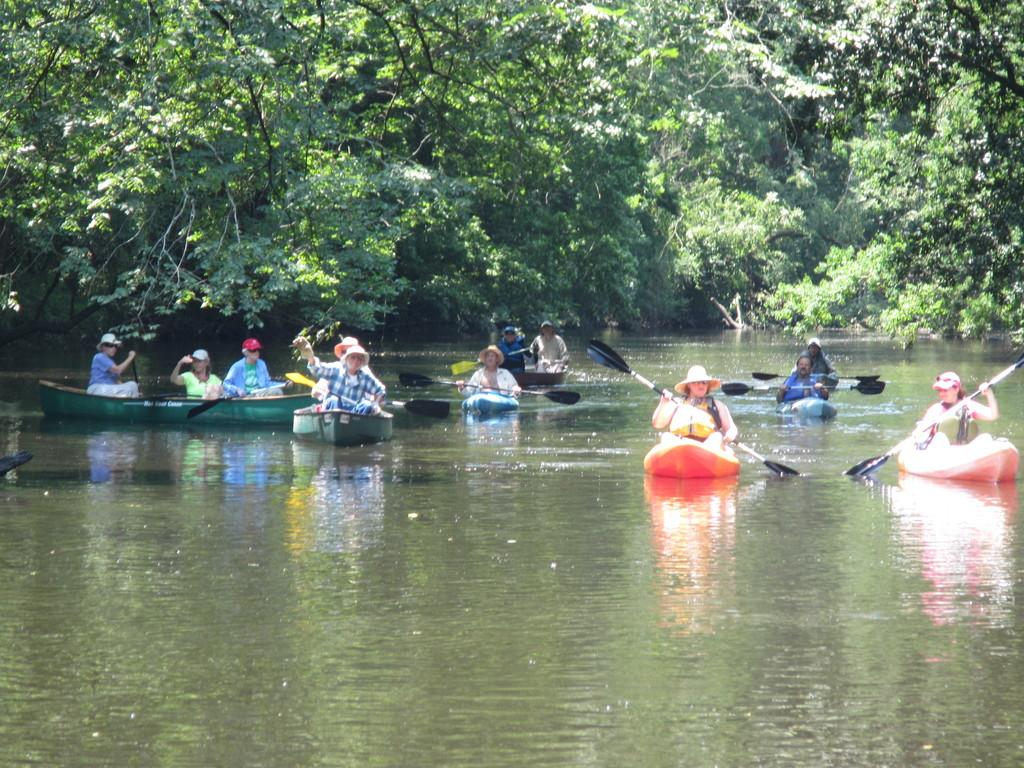What type of vehicles are in the image? There are boats in the image. Who is present in the image? There are people in the image. What are the people holding in the image? The people are holding paddles. Where are the boats located in the image? The boats are on the water. What can be seen in the background of the image? There are trees visible in the background of the image. What type of coal is being used to fuel the boats in the image? There is no coal present in the image, and the boats are not shown to be using any fuel. What kind of pie is being served to the people in the image? There is no pie present in the image; the people are holding paddles and are likely engaged in a water-based activity. 